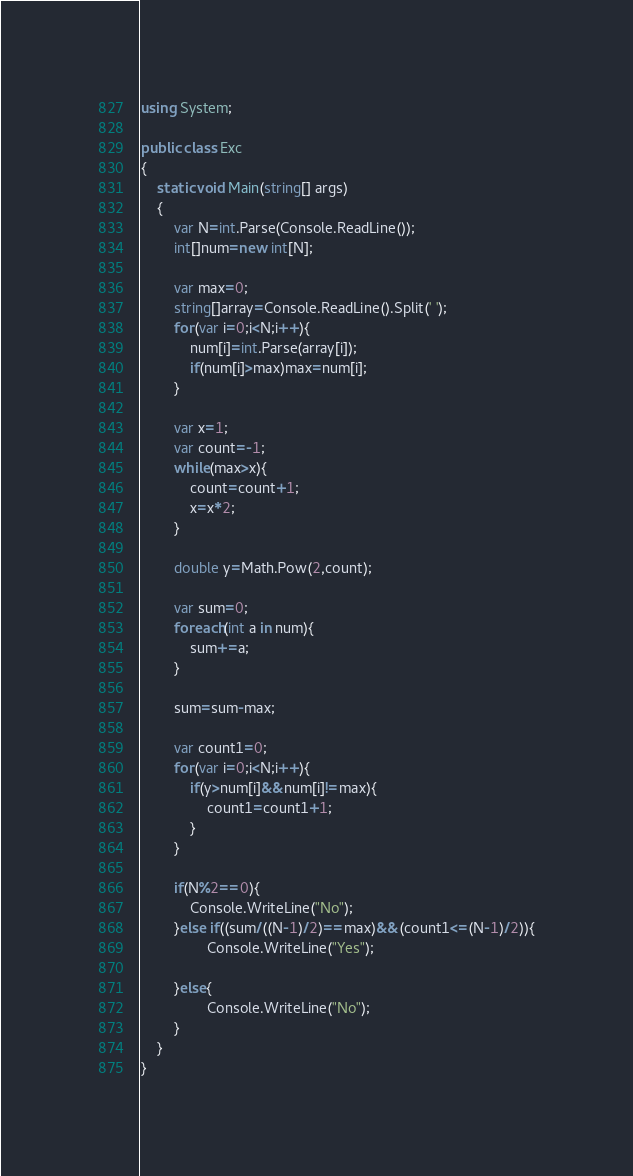<code> <loc_0><loc_0><loc_500><loc_500><_C#_>using System;

public class Exc
{
    static void Main(string[] args)
    {
        var N=int.Parse(Console.ReadLine());
        int[]num=new int[N];
        
        var max=0;
        string[]array=Console.ReadLine().Split(' ');
        for(var i=0;i<N;i++){
            num[i]=int.Parse(array[i]);
            if(num[i]>max)max=num[i];
        }
        
        var x=1;
        var count=-1;
        while(max>x){
            count=count+1;
            x=x*2;
        }
        
        double y=Math.Pow(2,count);
        
        var sum=0;
        foreach(int a in num){
            sum+=a;
        }
        
        sum=sum-max;
        
        var count1=0;
        for(var i=0;i<N;i++){
            if(y>num[i]&&num[i]!=max){
                count1=count1+1;
            }
        }
        
        if(N%2==0){
            Console.WriteLine("No");
        }else if((sum/((N-1)/2)==max)&&(count1<=(N-1)/2)){
                Console.WriteLine("Yes");
            
        }else{
                Console.WriteLine("No");
        }
    }
}</code> 